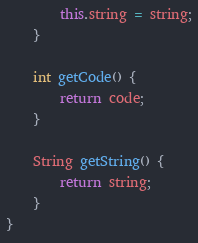Convert code to text. <code><loc_0><loc_0><loc_500><loc_500><_Java_>        this.string = string;
    }

    int getCode() {
        return code;
    }

    String getString() {
        return string;
    }
}
</code> 